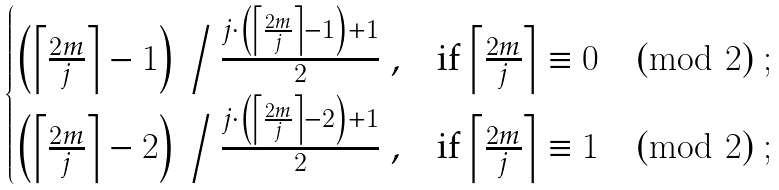<formula> <loc_0><loc_0><loc_500><loc_500>\begin{cases} \left ( \left \lceil \frac { 2 m } { j } \right \rceil - 1 \right ) \, \Big / \, \frac { j \cdot \left ( \left \lceil \frac { 2 m } { j } \right \rceil - 1 \right ) + 1 } { 2 } \ , & \text {if $\left\lceil\frac{2m}{j}\right\rceil\equiv 0\pmod{2}$} \ ; \\ \left ( \left \lceil \frac { 2 m } { j } \right \rceil - 2 \right ) \, \Big / \, \frac { j \cdot \left ( \left \lceil \frac { 2 m } { j } \right \rceil - 2 \right ) + 1 } { 2 } \ , & \text {if $\left\lceil\frac{2m}{j}\right\rceil\equiv 1\pmod{2}$} \ ; \end{cases}</formula> 